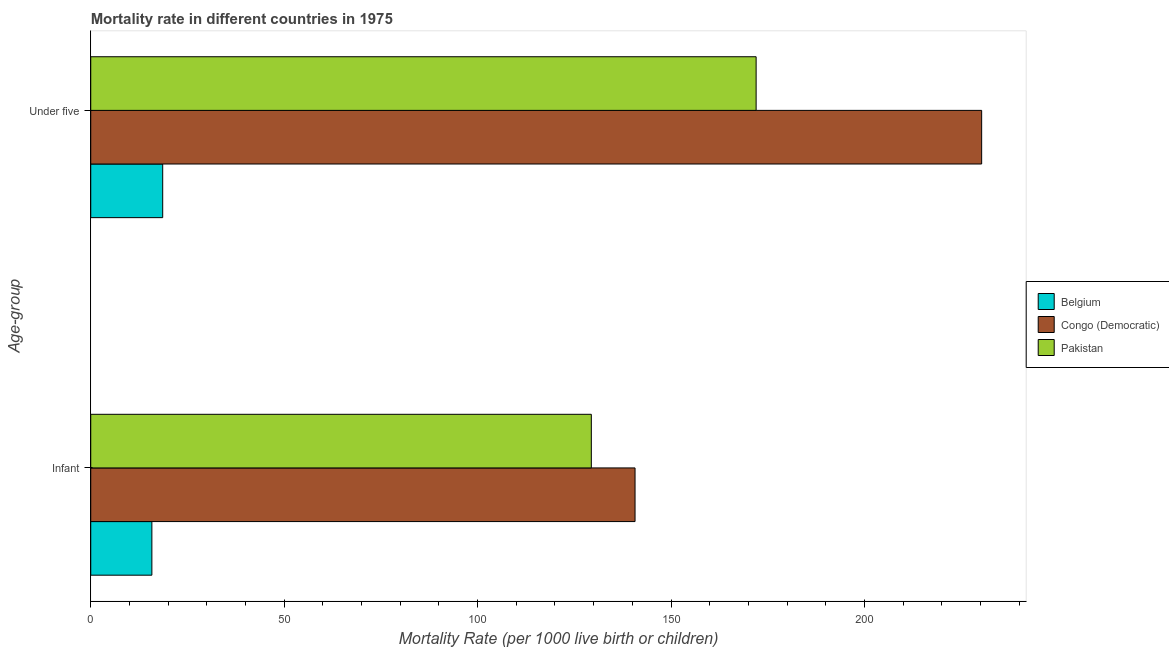How many different coloured bars are there?
Keep it short and to the point. 3. How many groups of bars are there?
Ensure brevity in your answer.  2. Are the number of bars per tick equal to the number of legend labels?
Your answer should be compact. Yes. Are the number of bars on each tick of the Y-axis equal?
Ensure brevity in your answer.  Yes. What is the label of the 1st group of bars from the top?
Provide a short and direct response. Under five. What is the under-5 mortality rate in Congo (Democratic)?
Keep it short and to the point. 230.3. Across all countries, what is the maximum under-5 mortality rate?
Offer a terse response. 230.3. Across all countries, what is the minimum infant mortality rate?
Make the answer very short. 15.8. In which country was the infant mortality rate maximum?
Your response must be concise. Congo (Democratic). In which country was the under-5 mortality rate minimum?
Keep it short and to the point. Belgium. What is the total under-5 mortality rate in the graph?
Keep it short and to the point. 420.9. What is the difference between the under-5 mortality rate in Belgium and that in Pakistan?
Give a very brief answer. -153.4. What is the difference between the infant mortality rate in Pakistan and the under-5 mortality rate in Belgium?
Offer a very short reply. 110.8. What is the average infant mortality rate per country?
Your response must be concise. 95.3. What is the difference between the under-5 mortality rate and infant mortality rate in Pakistan?
Your answer should be compact. 42.6. What is the ratio of the infant mortality rate in Pakistan to that in Congo (Democratic)?
Offer a terse response. 0.92. Is the infant mortality rate in Belgium less than that in Pakistan?
Your answer should be compact. Yes. What does the 3rd bar from the top in Under five represents?
Provide a short and direct response. Belgium. What does the 2nd bar from the bottom in Under five represents?
Provide a short and direct response. Congo (Democratic). What is the difference between two consecutive major ticks on the X-axis?
Provide a short and direct response. 50. Are the values on the major ticks of X-axis written in scientific E-notation?
Ensure brevity in your answer.  No. How are the legend labels stacked?
Keep it short and to the point. Vertical. What is the title of the graph?
Give a very brief answer. Mortality rate in different countries in 1975. What is the label or title of the X-axis?
Offer a very short reply. Mortality Rate (per 1000 live birth or children). What is the label or title of the Y-axis?
Offer a terse response. Age-group. What is the Mortality Rate (per 1000 live birth or children) of Belgium in Infant?
Your answer should be compact. 15.8. What is the Mortality Rate (per 1000 live birth or children) in Congo (Democratic) in Infant?
Give a very brief answer. 140.7. What is the Mortality Rate (per 1000 live birth or children) in Pakistan in Infant?
Your answer should be compact. 129.4. What is the Mortality Rate (per 1000 live birth or children) in Congo (Democratic) in Under five?
Offer a terse response. 230.3. What is the Mortality Rate (per 1000 live birth or children) of Pakistan in Under five?
Your answer should be very brief. 172. Across all Age-group, what is the maximum Mortality Rate (per 1000 live birth or children) of Belgium?
Ensure brevity in your answer.  18.6. Across all Age-group, what is the maximum Mortality Rate (per 1000 live birth or children) of Congo (Democratic)?
Your answer should be very brief. 230.3. Across all Age-group, what is the maximum Mortality Rate (per 1000 live birth or children) of Pakistan?
Your response must be concise. 172. Across all Age-group, what is the minimum Mortality Rate (per 1000 live birth or children) in Belgium?
Provide a short and direct response. 15.8. Across all Age-group, what is the minimum Mortality Rate (per 1000 live birth or children) in Congo (Democratic)?
Your response must be concise. 140.7. Across all Age-group, what is the minimum Mortality Rate (per 1000 live birth or children) in Pakistan?
Your answer should be compact. 129.4. What is the total Mortality Rate (per 1000 live birth or children) of Belgium in the graph?
Your answer should be very brief. 34.4. What is the total Mortality Rate (per 1000 live birth or children) of Congo (Democratic) in the graph?
Make the answer very short. 371. What is the total Mortality Rate (per 1000 live birth or children) of Pakistan in the graph?
Give a very brief answer. 301.4. What is the difference between the Mortality Rate (per 1000 live birth or children) of Congo (Democratic) in Infant and that in Under five?
Offer a very short reply. -89.6. What is the difference between the Mortality Rate (per 1000 live birth or children) of Pakistan in Infant and that in Under five?
Your answer should be compact. -42.6. What is the difference between the Mortality Rate (per 1000 live birth or children) of Belgium in Infant and the Mortality Rate (per 1000 live birth or children) of Congo (Democratic) in Under five?
Keep it short and to the point. -214.5. What is the difference between the Mortality Rate (per 1000 live birth or children) of Belgium in Infant and the Mortality Rate (per 1000 live birth or children) of Pakistan in Under five?
Give a very brief answer. -156.2. What is the difference between the Mortality Rate (per 1000 live birth or children) of Congo (Democratic) in Infant and the Mortality Rate (per 1000 live birth or children) of Pakistan in Under five?
Your answer should be compact. -31.3. What is the average Mortality Rate (per 1000 live birth or children) of Belgium per Age-group?
Your answer should be very brief. 17.2. What is the average Mortality Rate (per 1000 live birth or children) of Congo (Democratic) per Age-group?
Your response must be concise. 185.5. What is the average Mortality Rate (per 1000 live birth or children) of Pakistan per Age-group?
Your answer should be compact. 150.7. What is the difference between the Mortality Rate (per 1000 live birth or children) in Belgium and Mortality Rate (per 1000 live birth or children) in Congo (Democratic) in Infant?
Give a very brief answer. -124.9. What is the difference between the Mortality Rate (per 1000 live birth or children) of Belgium and Mortality Rate (per 1000 live birth or children) of Pakistan in Infant?
Provide a short and direct response. -113.6. What is the difference between the Mortality Rate (per 1000 live birth or children) of Congo (Democratic) and Mortality Rate (per 1000 live birth or children) of Pakistan in Infant?
Offer a very short reply. 11.3. What is the difference between the Mortality Rate (per 1000 live birth or children) of Belgium and Mortality Rate (per 1000 live birth or children) of Congo (Democratic) in Under five?
Keep it short and to the point. -211.7. What is the difference between the Mortality Rate (per 1000 live birth or children) in Belgium and Mortality Rate (per 1000 live birth or children) in Pakistan in Under five?
Make the answer very short. -153.4. What is the difference between the Mortality Rate (per 1000 live birth or children) in Congo (Democratic) and Mortality Rate (per 1000 live birth or children) in Pakistan in Under five?
Your answer should be compact. 58.3. What is the ratio of the Mortality Rate (per 1000 live birth or children) in Belgium in Infant to that in Under five?
Keep it short and to the point. 0.85. What is the ratio of the Mortality Rate (per 1000 live birth or children) in Congo (Democratic) in Infant to that in Under five?
Offer a very short reply. 0.61. What is the ratio of the Mortality Rate (per 1000 live birth or children) in Pakistan in Infant to that in Under five?
Make the answer very short. 0.75. What is the difference between the highest and the second highest Mortality Rate (per 1000 live birth or children) in Belgium?
Offer a very short reply. 2.8. What is the difference between the highest and the second highest Mortality Rate (per 1000 live birth or children) in Congo (Democratic)?
Offer a very short reply. 89.6. What is the difference between the highest and the second highest Mortality Rate (per 1000 live birth or children) in Pakistan?
Your answer should be very brief. 42.6. What is the difference between the highest and the lowest Mortality Rate (per 1000 live birth or children) in Congo (Democratic)?
Offer a terse response. 89.6. What is the difference between the highest and the lowest Mortality Rate (per 1000 live birth or children) of Pakistan?
Ensure brevity in your answer.  42.6. 